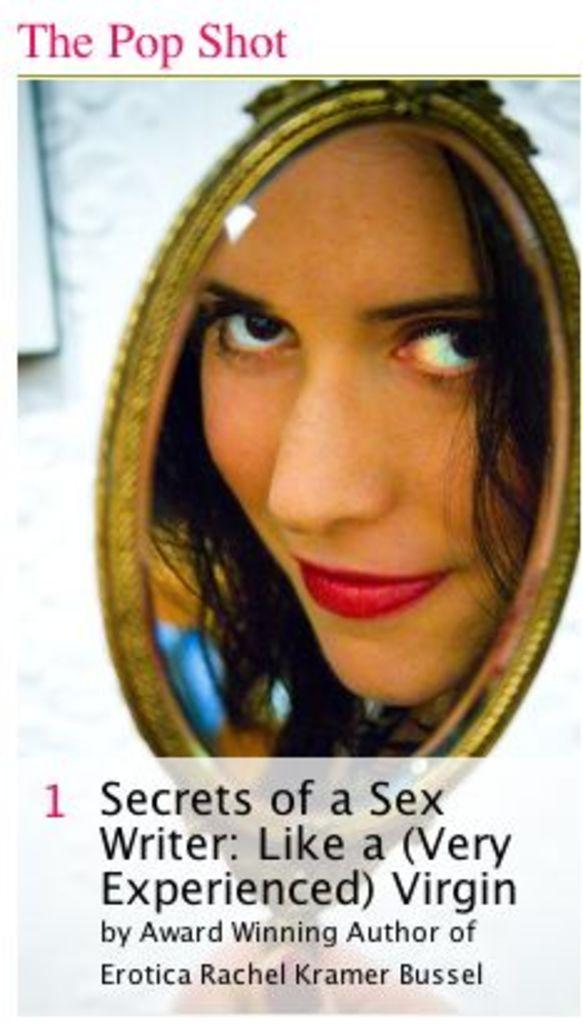What is the main subject of the image? The main subject of the image is a woman's face. Is there any text present in the image? Yes, there is some text at the bottom of the image. What type of border is surrounding the woman's face in the image? There is no border surrounding the woman's face in the image. What is the temperature like in the image? The image does not provide any information about the temperature or heat. 